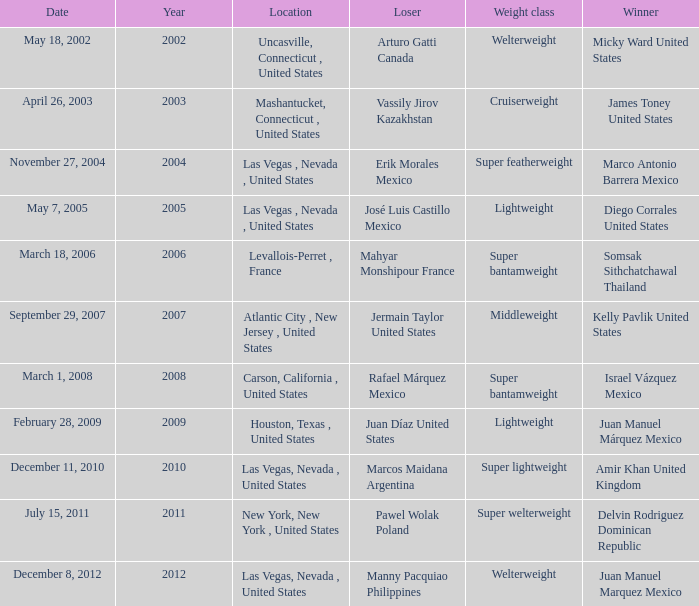How many years were lightweight class on february 28, 2009? 1.0. 